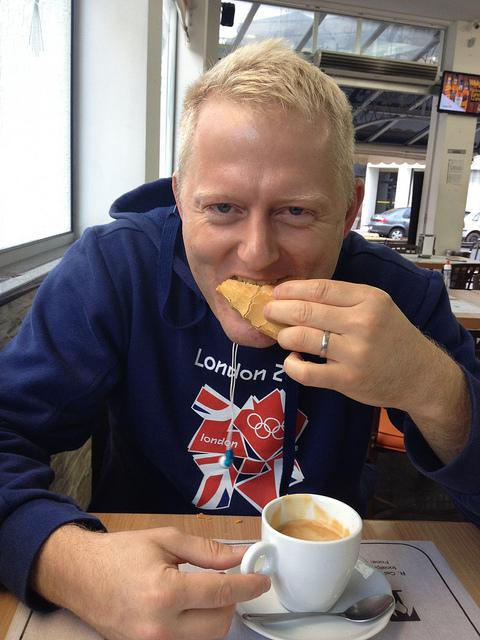Is this man married?
Be succinct. Yes. What city is on his shirt?
Give a very brief answer. London. What color is this man's hair?
Quick response, please. Blonde. 